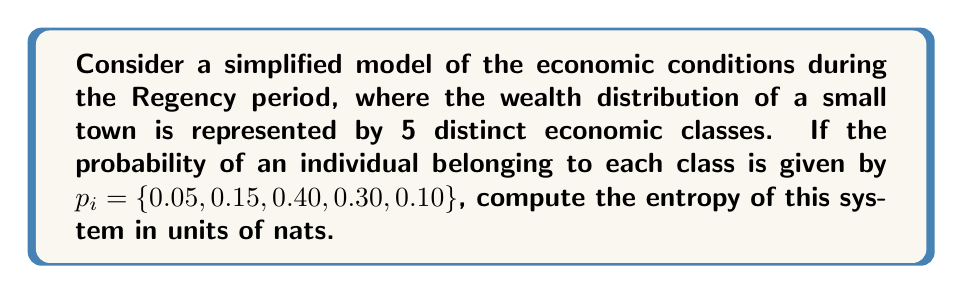Can you solve this math problem? To compute the entropy of this system, we'll use the Shannon entropy formula:

$$S = -\sum_{i=1}^{n} p_i \ln(p_i)$$

Where $S$ is the entropy, $p_i$ is the probability of an individual belonging to each economic class, and $n$ is the number of classes.

Let's calculate each term:

1. $-0.05 \ln(0.05) = 0.14977$
2. $-0.15 \ln(0.15) = 0.28639$
3. $-0.40 \ln(0.40) = 0.36652$
4. $-0.30 \ln(0.30) = 0.36119$
5. $-0.10 \ln(0.10) = 0.23026$

Now, sum all these terms:

$$S = 0.14977 + 0.28639 + 0.36652 + 0.36119 + 0.23026$$

$$S = 1.39413$$

The entropy of the system is approximately 1.39413 nats.
Answer: 1.39413 nats 